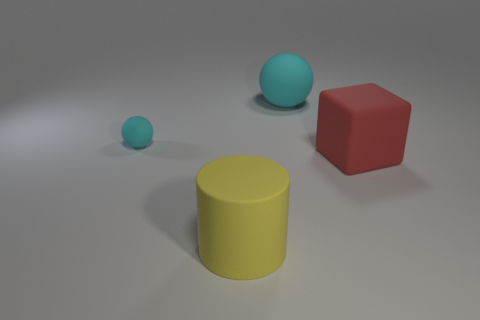There is a sphere that is on the right side of the yellow thing; how many cyan matte objects are right of it?
Keep it short and to the point. 0. How many shiny things are large yellow cylinders or large spheres?
Give a very brief answer. 0. Is there a large red sphere made of the same material as the tiny cyan sphere?
Keep it short and to the point. No. What number of things are matte spheres on the right side of the large yellow rubber cylinder or spheres that are to the right of the yellow rubber cylinder?
Your answer should be very brief. 1. Does the sphere that is to the left of the big cyan sphere have the same color as the big sphere?
Make the answer very short. Yes. How many other objects are there of the same color as the big ball?
Keep it short and to the point. 1. There is a ball right of the matte cylinder; is it the same size as the tiny cyan matte thing?
Offer a terse response. No. Is there any other thing that has the same size as the yellow rubber thing?
Make the answer very short. Yes. What is the size of the other matte thing that is the same shape as the small matte thing?
Keep it short and to the point. Large. Are there the same number of big red matte blocks that are behind the big red cube and spheres that are left of the yellow thing?
Your answer should be compact. No. 